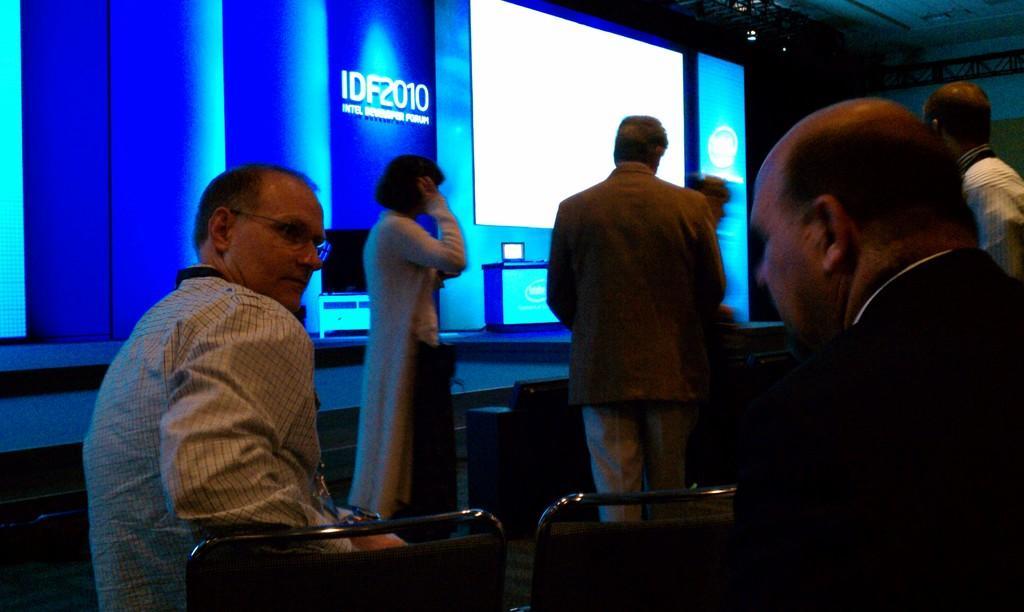Can you describe this image briefly? In the picture I can see two persons sitting in chairs and there are four persons standing in front of them and there is a projector and some other objects in the background. 